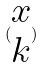Convert formula to latex. <formula><loc_0><loc_0><loc_500><loc_500>( \begin{matrix} x \\ k \end{matrix} )</formula> 